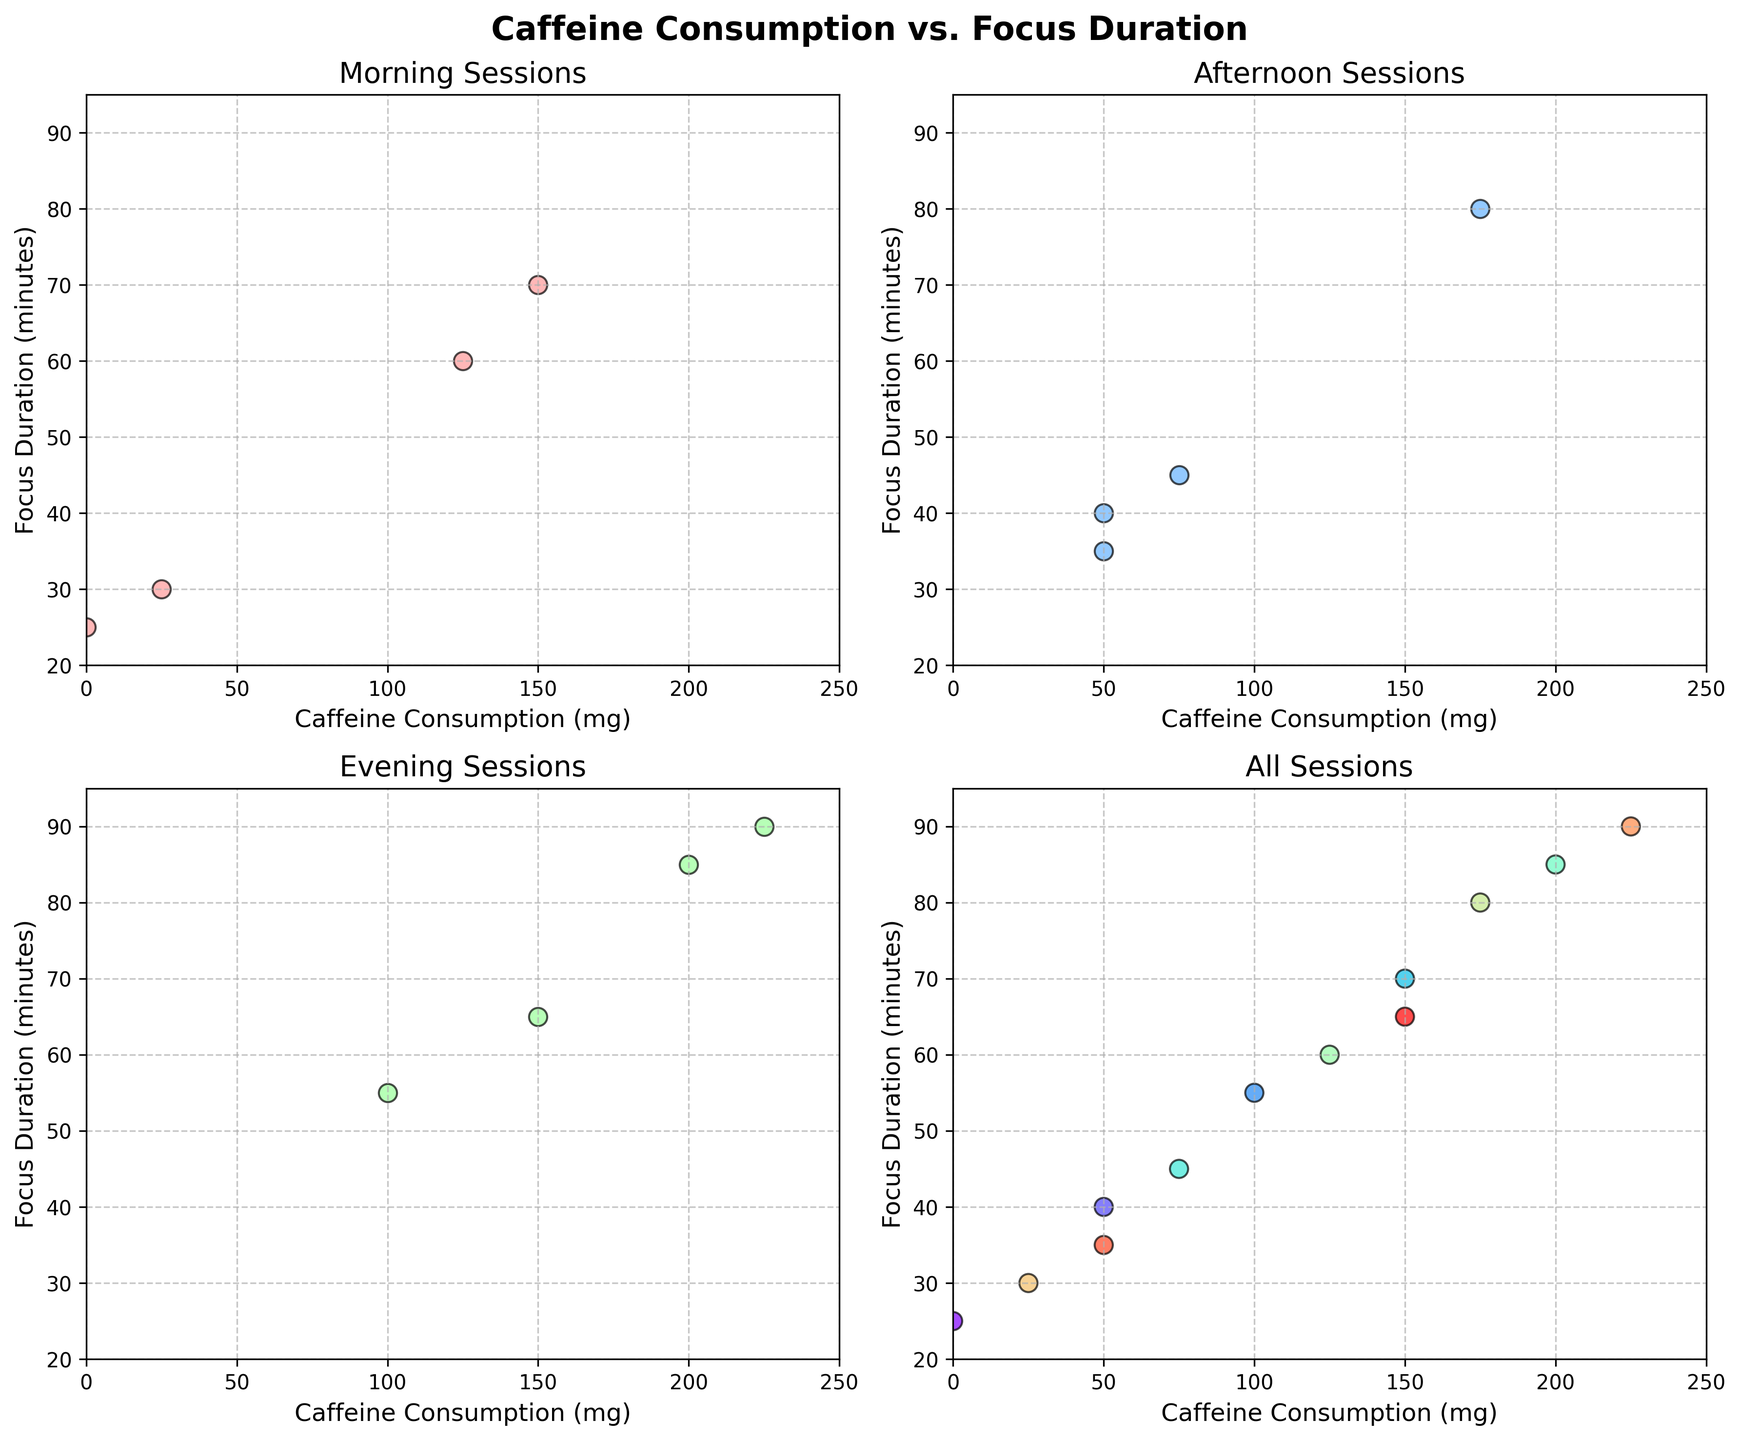What is the title of the figure? The title of the figure is located at the top of the subplot, formatted in bold and larger font size.
Answer: Caffeine Consumption vs. Focus Duration How many subplots are there in the figure? There are four subplots arranged in a 2x2 grid in the figure.
Answer: 4 What is the color of the points in the 'Morning Sessions' subplot? The points in the 'Morning Sessions' subplot are colored in light red.
Answer: Light red What is the range of caffeine consumption values displayed in the 'All Sessions' subplot? The x-axis of the 'All Sessions' subplot shows the caffeine consumption ranging from 0 to 250 mg.
Answer: 0 to 250 mg Which session has the highest focus duration, and what is the caffeine consumed during that session? The subplot for all sessions indicates that the Saturday Evening session has the highest focus duration with 90 minutes, and the caffeine consumed is 225 mg.
Answer: Saturday Evening, 225 mg Compare the focus durations of the Monday Afternoon and Sunday Afternoon sessions. Which one is higher, and by how much? Observing the 'Afternoon' subplot, the Monday Afternoon session has a focus duration of 40 minutes while the Sunday Afternoon session has 35 minutes. Therefore, the Monday Afternoon session is higher by 5 minutes.
Answer: Monday Afternoon, by 5 minutes What is the most prevalent time of day for sessions with high caffeine consumption (above 150 mg)? The 'All Sessions' subplot can be examined to find that most high caffeine consumption sessions (above 150 mg) occur in the Evening.
Answer: Evening Calculate the average focus duration for morning sessions. In the 'Morning Sessions' subplot, there's Monday Morning (25 minutes), Wednesday Morning (70 minutes), Friday Morning (60 minutes), and Saturday Morning (30 minutes). \((25+70+60+30)/4 = 46.25\)
Answer: 46.25 minutes How does the focus duration trend change from 'Morning' to 'Evening' sessions? Comparing the 'Morning', 'Afternoon', and 'Evening' subplots, focus duration tends to increase from morning to evening sessions.
Answer: Increases 